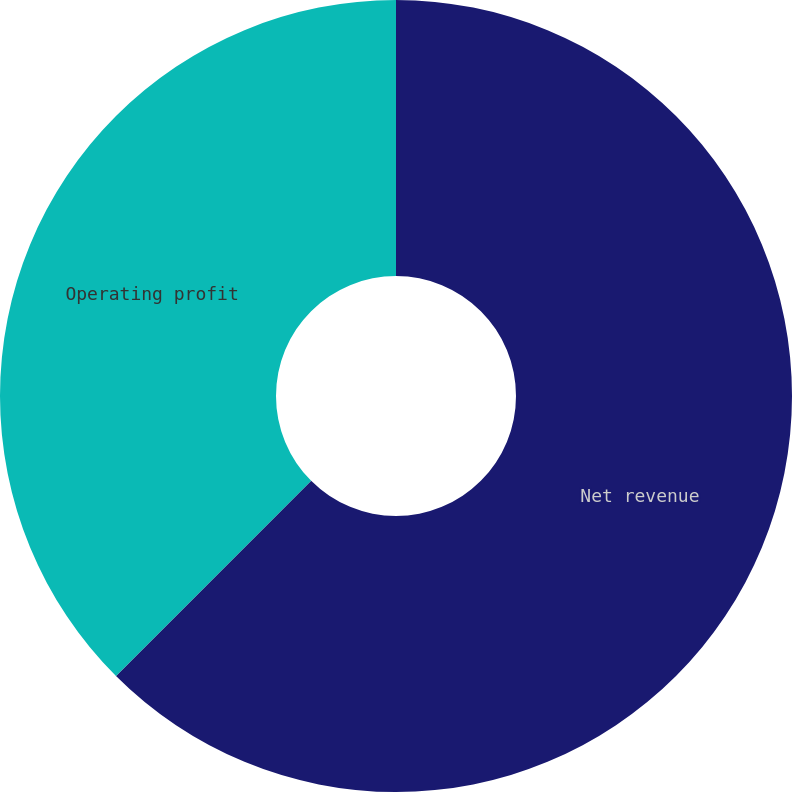Convert chart. <chart><loc_0><loc_0><loc_500><loc_500><pie_chart><fcel>Net revenue<fcel>Operating profit<nl><fcel>62.5%<fcel>37.5%<nl></chart> 